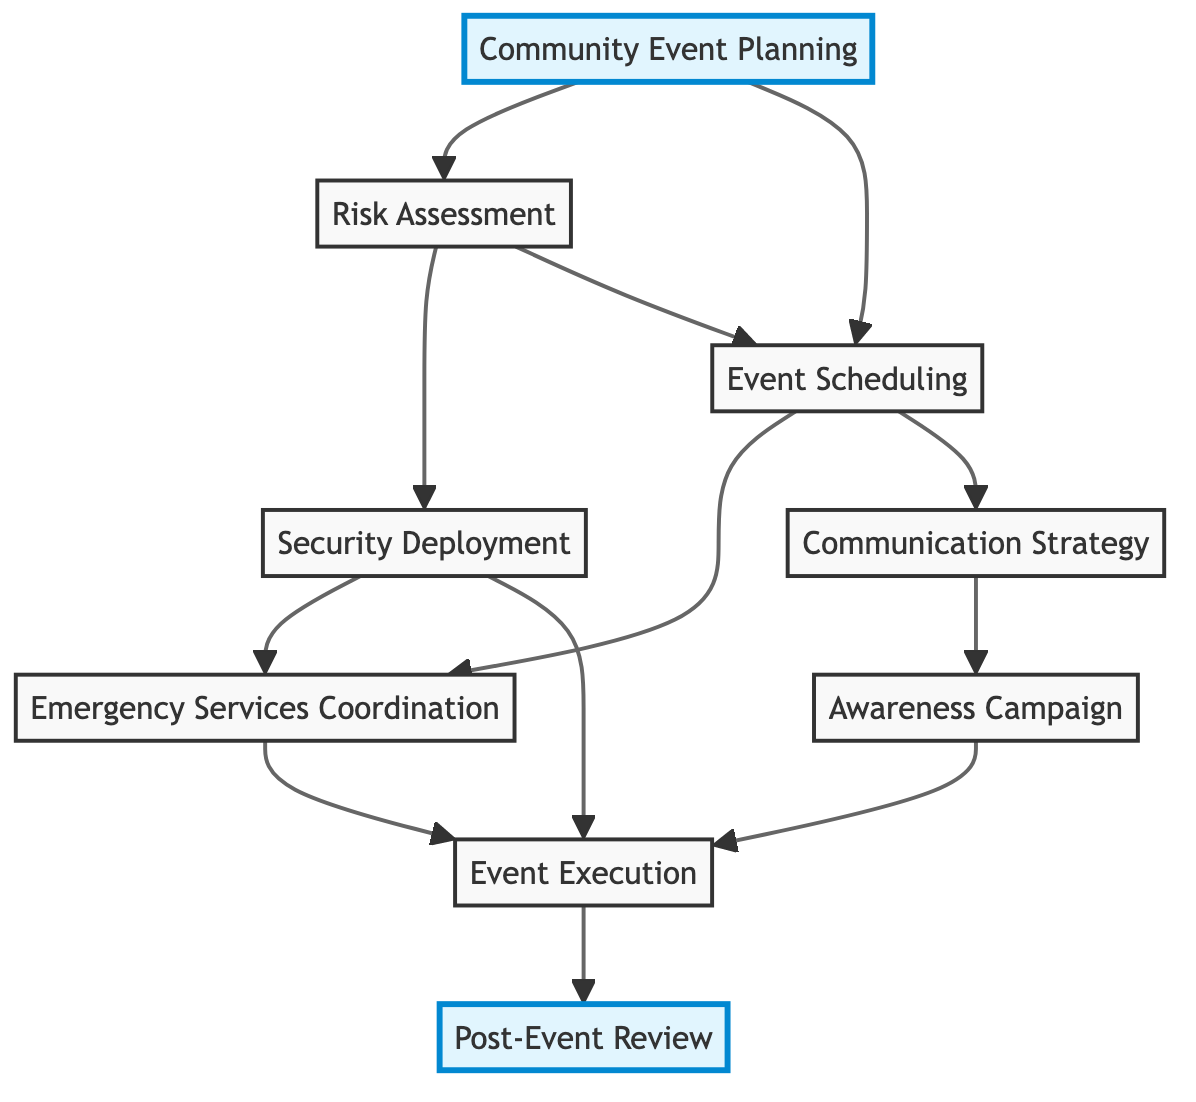What is the starting point of the diagram? The diagram begins with the block labeled "Community Event Planning", as it is the first node with arrows leading to two other nodes.
Answer: Community Event Planning How many connections does the "Event Scheduling" block have? The "Event Scheduling" block connects to two other blocks ("Emergency Services Coordination" and "Communication Strategy"), making a total of two connections.
Answer: 2 Which block follows "Security Deployment"? After "Security Deployment", the flow continues to "Emergency Services Coordination" and "Event Execution" since "Security Deployment" has arrows pointing to both of these blocks.
Answer: Emergency Services Coordination, Event Execution What is the last block in the diagram? The last block is "Post-Event Review," which is the final node in the flow of the diagram and has no outgoing connections.
Answer: Post-Event Review Describe the relationship between "Communication Strategy" and "Awareness Campaign." "Communication Strategy" connects to "Awareness Campaign," indicating that after establishing communication channels, the awareness campaign is initiated.
Answer: Establishes Which block involves the evaluation of risks related to the event? The "Risk Assessment" block is specifically designed to evaluate potential risks and determine safety measures for the event.
Answer: Risk Assessment What block has the highest number of outgoing connections? The block "Event Scheduling" has the highest number of outgoing connections, leading to two blocks, which are "Emergency Services Coordination" and "Communication Strategy."
Answer: Event Scheduling What is the purpose of the "Post-Event Review" block? The purpose of the "Post-Event Review" block is to evaluate the event's success while identifying areas requiring improvement based on the outcomes of the event.
Answer: Evaluate success How many total blocks are in the diagram? The diagram consists of nine blocks total, each representing a different aspect of the coordination process with the security company for community events.
Answer: 9 